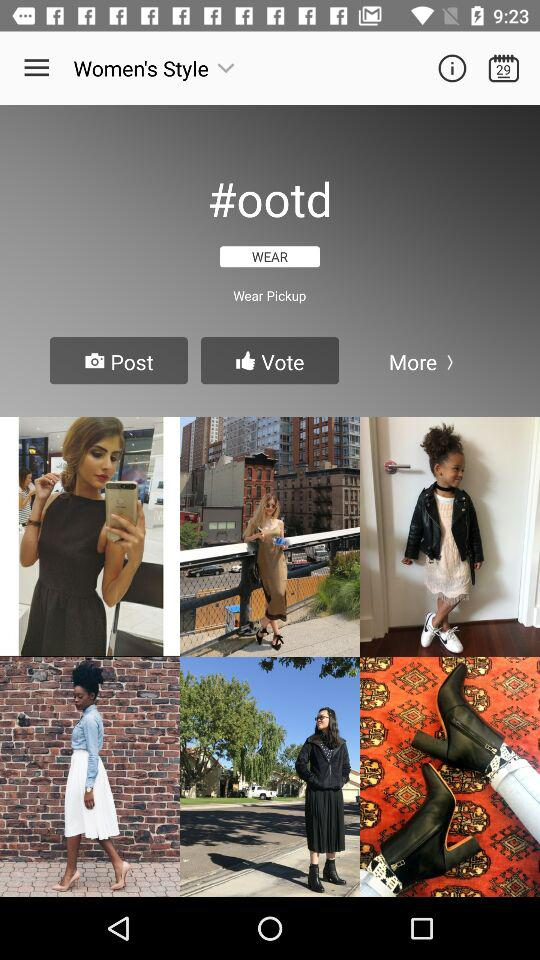What is the date? The date is 29. 